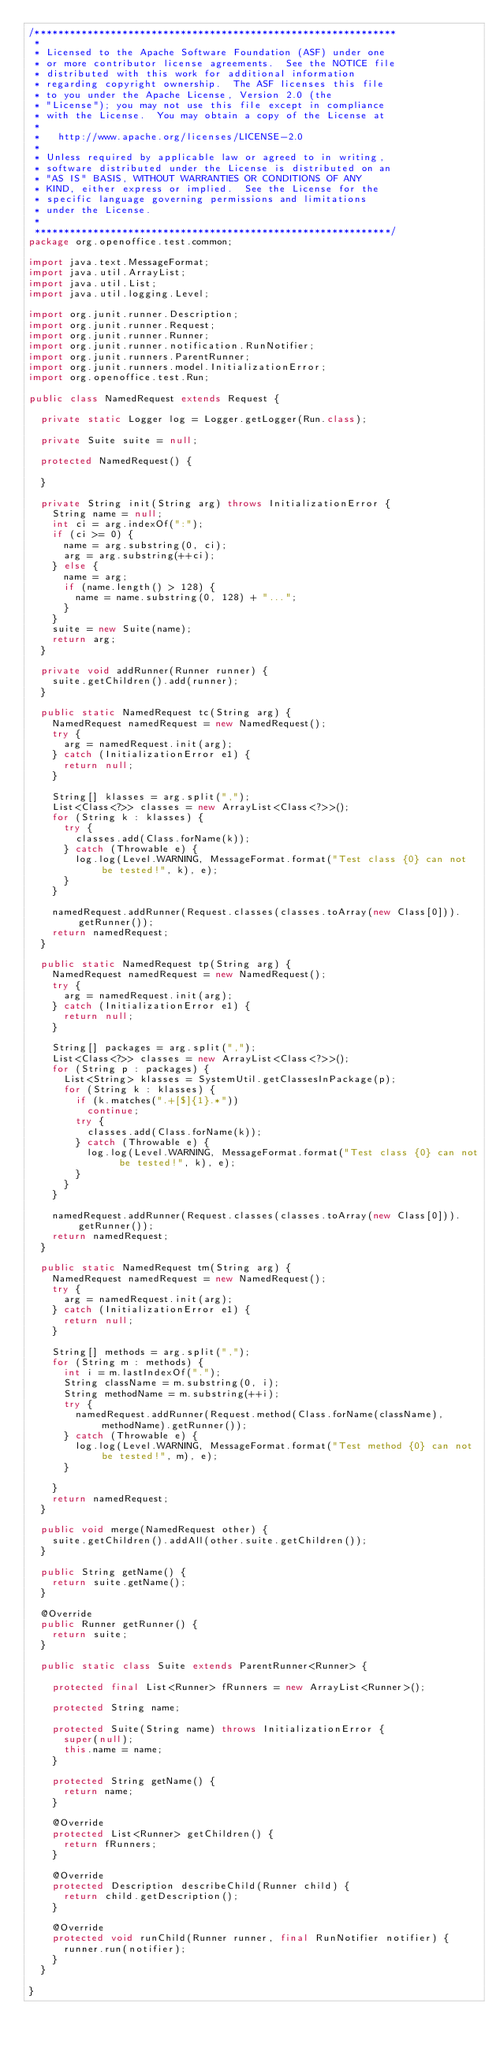Convert code to text. <code><loc_0><loc_0><loc_500><loc_500><_Java_>/**************************************************************
 * 
 * Licensed to the Apache Software Foundation (ASF) under one
 * or more contributor license agreements.  See the NOTICE file
 * distributed with this work for additional information
 * regarding copyright ownership.  The ASF licenses this file
 * to you under the Apache License, Version 2.0 (the
 * "License"); you may not use this file except in compliance
 * with the License.  You may obtain a copy of the License at
 * 
 *   http://www.apache.org/licenses/LICENSE-2.0
 * 
 * Unless required by applicable law or agreed to in writing,
 * software distributed under the License is distributed on an
 * "AS IS" BASIS, WITHOUT WARRANTIES OR CONDITIONS OF ANY
 * KIND, either express or implied.  See the License for the
 * specific language governing permissions and limitations
 * under the License.
 * 
 *************************************************************/
package org.openoffice.test.common;

import java.text.MessageFormat;
import java.util.ArrayList;
import java.util.List;
import java.util.logging.Level;

import org.junit.runner.Description;
import org.junit.runner.Request;
import org.junit.runner.Runner;
import org.junit.runner.notification.RunNotifier;
import org.junit.runners.ParentRunner;
import org.junit.runners.model.InitializationError;
import org.openoffice.test.Run;

public class NamedRequest extends Request {
	
	private static Logger log = Logger.getLogger(Run.class);
	
	private Suite suite = null;
	
	protected NamedRequest() {
		
	}
	
	private String init(String arg) throws InitializationError {
		String name = null;
		int ci = arg.indexOf(":");
		if (ci >= 0) {
			name = arg.substring(0, ci);
			arg = arg.substring(++ci);
		} else {
			name = arg;
			if (name.length() > 128) {
				name = name.substring(0, 128) + "...";
			}
		}
		suite = new Suite(name);
		return arg;
	}
	
	private void addRunner(Runner runner) {
		suite.getChildren().add(runner);
	}
	
	public static NamedRequest tc(String arg) {
		NamedRequest namedRequest = new NamedRequest();
		try {
			arg = namedRequest.init(arg);
		} catch (InitializationError e1) {
			return null;
		}
		
		String[] klasses = arg.split(",");
		List<Class<?>> classes = new ArrayList<Class<?>>();
		for (String k : klasses) {
			try {
				classes.add(Class.forName(k));
			} catch (Throwable e) {
				log.log(Level.WARNING, MessageFormat.format("Test class {0} can not be tested!", k), e);
			}
		}
		
		namedRequest.addRunner(Request.classes(classes.toArray(new Class[0])).getRunner());
		return namedRequest;
	}
	
	public static NamedRequest tp(String arg) {
		NamedRequest namedRequest = new NamedRequest();
		try {
			arg = namedRequest.init(arg);
		} catch (InitializationError e1) {
			return null;
		}
		
		String[] packages = arg.split(",");
		List<Class<?>> classes = new ArrayList<Class<?>>();
		for (String p : packages) {
			List<String> klasses = SystemUtil.getClassesInPackage(p);
			for (String k : klasses) {
				if (k.matches(".+[$]{1}.*"))
					continue;
				try {
					classes.add(Class.forName(k));
				} catch (Throwable e) {
					log.log(Level.WARNING, MessageFormat.format("Test class {0} can not be tested!", k), e);
				}
			}
		}
		
		namedRequest.addRunner(Request.classes(classes.toArray(new Class[0])).getRunner());
		return namedRequest;
	}

	public static NamedRequest tm(String arg) {
		NamedRequest namedRequest = new NamedRequest();
		try {
			arg = namedRequest.init(arg);
		} catch (InitializationError e1) {
			return null;
		}
		
		String[] methods = arg.split(",");
		for (String m : methods) {
			int i = m.lastIndexOf(".");
			String className = m.substring(0, i);
			String methodName = m.substring(++i);
			try {
				namedRequest.addRunner(Request.method(Class.forName(className), methodName).getRunner());
			} catch (Throwable e) {
				log.log(Level.WARNING, MessageFormat.format("Test method {0} can not be tested!", m), e);
			}
			
		}
		return namedRequest;
	}

	public void merge(NamedRequest other) {
		suite.getChildren().addAll(other.suite.getChildren());
	}

	public String getName() {
		return suite.getName();
	}

	@Override
	public Runner getRunner() {
		return suite;
	}
	
	public static class Suite extends ParentRunner<Runner> {
		
		protected final List<Runner> fRunners = new ArrayList<Runner>();

		protected String name;
		
		protected Suite(String name) throws InitializationError {
			super(null);
			this.name = name;
		}

		protected String getName() {
			return name;
		}
		
		@Override
		protected List<Runner> getChildren() {
			return fRunners;
		}

		@Override
		protected Description describeChild(Runner child) {
			return child.getDescription();
		}

		@Override
		protected void runChild(Runner runner, final RunNotifier notifier) {
			runner.run(notifier);
		}
	}

}</code> 